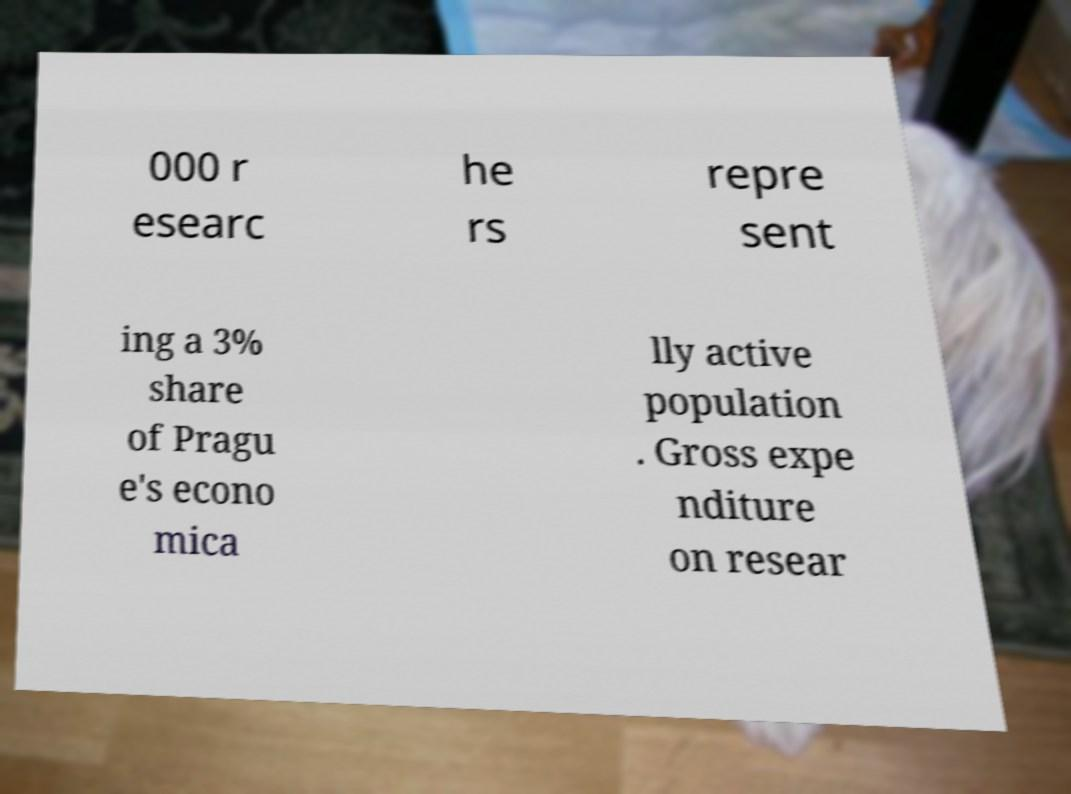Please identify and transcribe the text found in this image. 000 r esearc he rs repre sent ing a 3% share of Pragu e's econo mica lly active population . Gross expe nditure on resear 